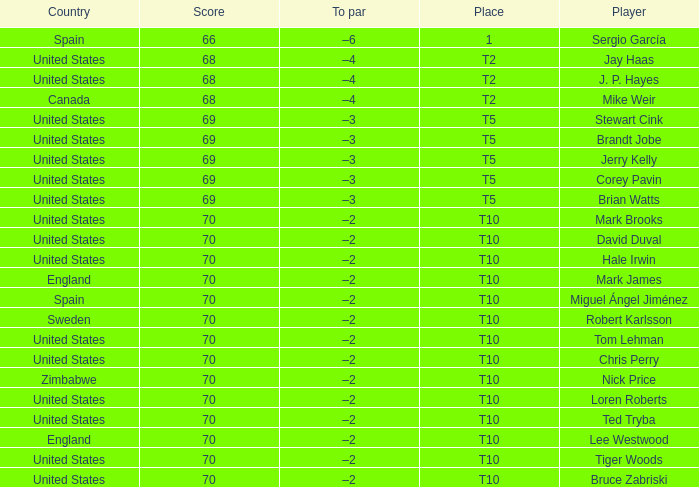What was the highest score of t5 place finisher brandt jobe? 69.0. 